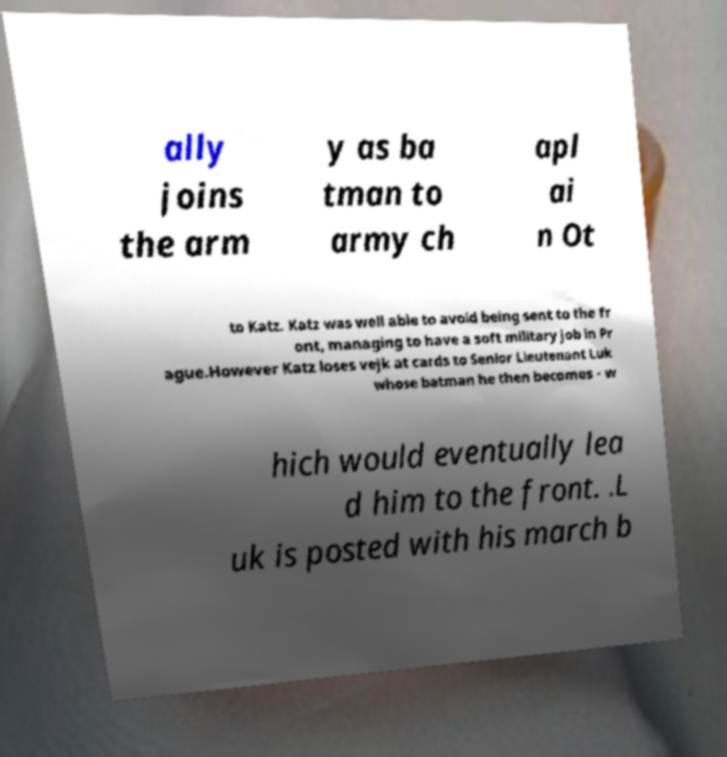There's text embedded in this image that I need extracted. Can you transcribe it verbatim? ally joins the arm y as ba tman to army ch apl ai n Ot to Katz. Katz was well able to avoid being sent to the fr ont, managing to have a soft military job in Pr ague.However Katz loses vejk at cards to Senior Lieutenant Luk whose batman he then becomes - w hich would eventually lea d him to the front. .L uk is posted with his march b 